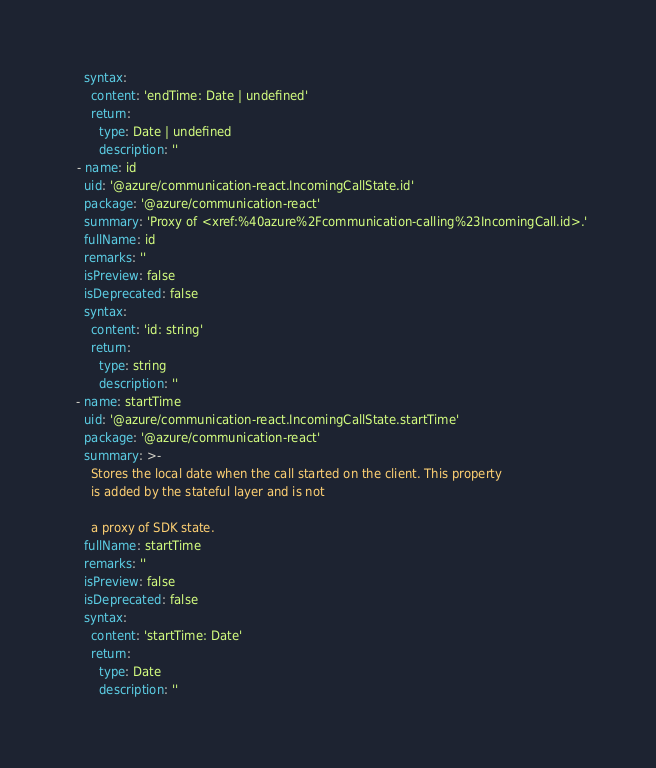<code> <loc_0><loc_0><loc_500><loc_500><_YAML_>    syntax:
      content: 'endTime: Date | undefined'
      return:
        type: Date | undefined
        description: ''
  - name: id
    uid: '@azure/communication-react.IncomingCallState.id'
    package: '@azure/communication-react'
    summary: 'Proxy of <xref:%40azure%2Fcommunication-calling%23IncomingCall.id>.'
    fullName: id
    remarks: ''
    isPreview: false
    isDeprecated: false
    syntax:
      content: 'id: string'
      return:
        type: string
        description: ''
  - name: startTime
    uid: '@azure/communication-react.IncomingCallState.startTime'
    package: '@azure/communication-react'
    summary: >-
      Stores the local date when the call started on the client. This property
      is added by the stateful layer and is not

      a proxy of SDK state.
    fullName: startTime
    remarks: ''
    isPreview: false
    isDeprecated: false
    syntax:
      content: 'startTime: Date'
      return:
        type: Date
        description: ''
</code> 